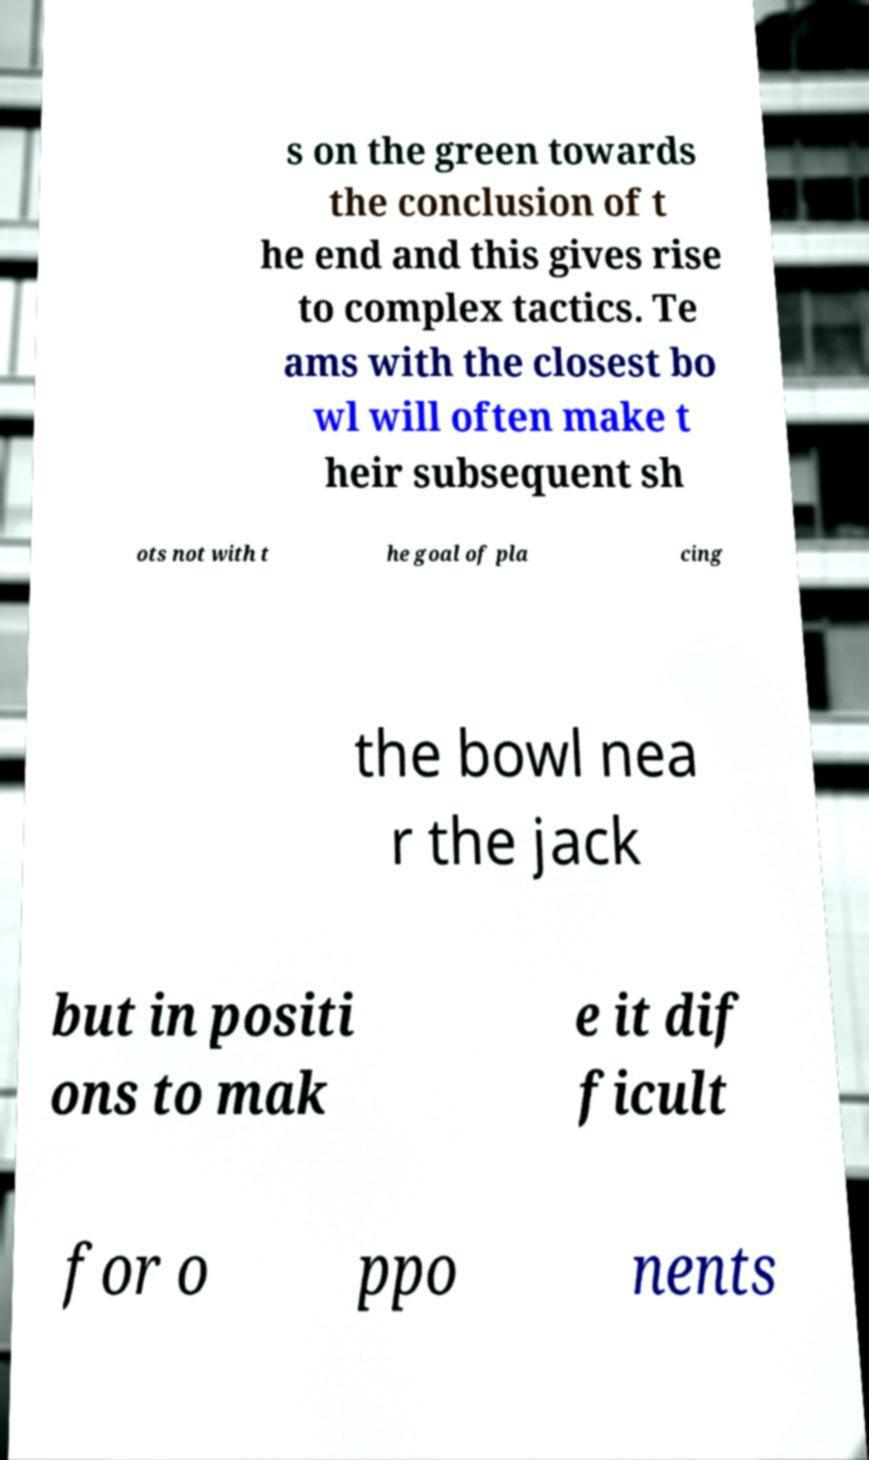Can you accurately transcribe the text from the provided image for me? s on the green towards the conclusion of t he end and this gives rise to complex tactics. Te ams with the closest bo wl will often make t heir subsequent sh ots not with t he goal of pla cing the bowl nea r the jack but in positi ons to mak e it dif ficult for o ppo nents 